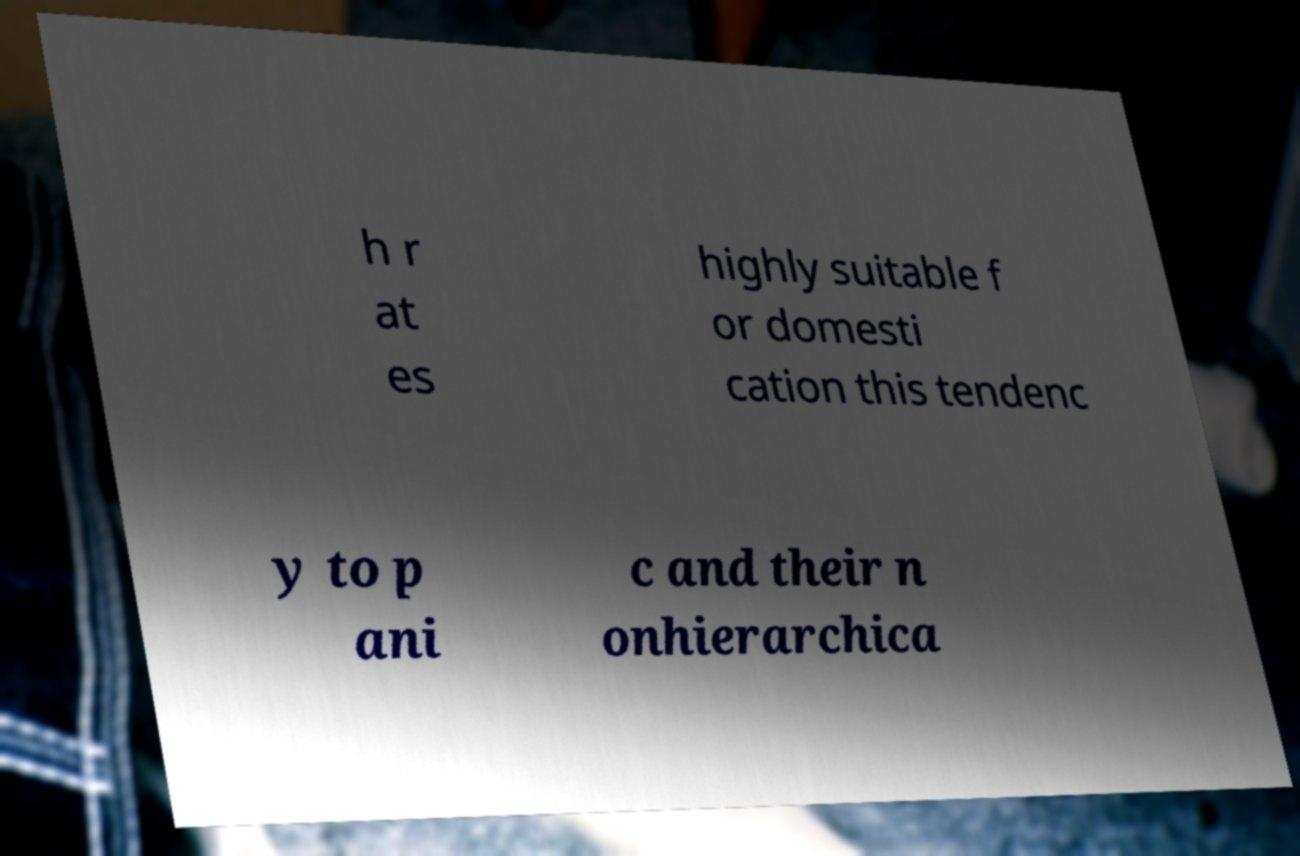Can you accurately transcribe the text from the provided image for me? h r at es highly suitable f or domesti cation this tendenc y to p ani c and their n onhierarchica 